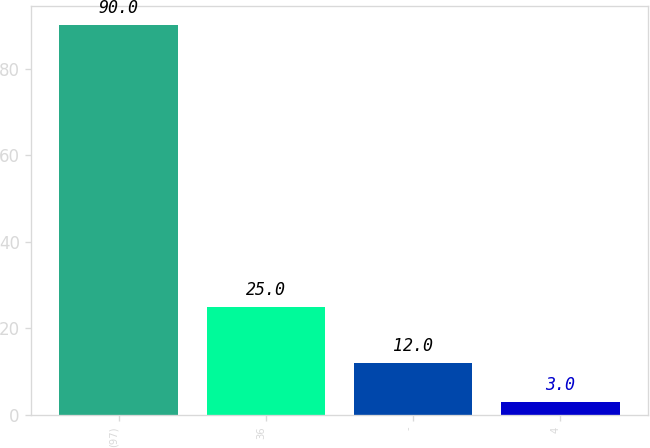Convert chart. <chart><loc_0><loc_0><loc_500><loc_500><bar_chart><fcel>(97)<fcel>36<fcel>-<fcel>4<nl><fcel>90<fcel>25<fcel>12<fcel>3<nl></chart> 